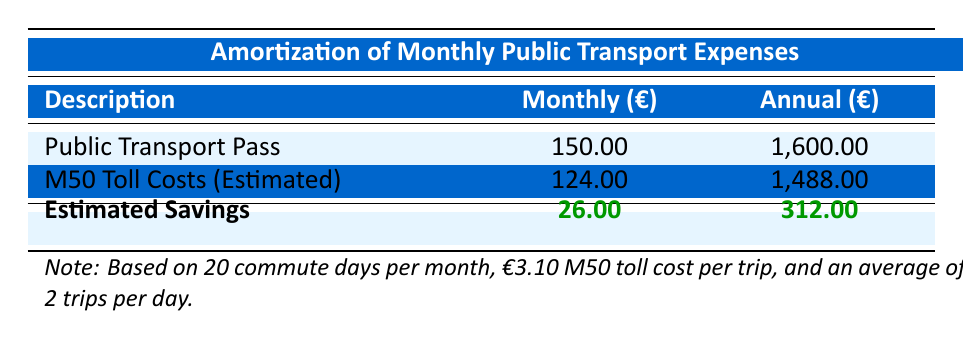What is the monthly cost for a public transport pass? The table directly states that the cost for a Public Transport Pass is €150.00 per month.
Answer: 150.00 How much can a commuter save annually by opting for public transport? The table shows that the Annual Savings from Public Transport is €312.00.
Answer: 312.00 What is the difference in annual costs between the public transport pass and M50 toll costs? The Annual Public Transport Pass cost is €1,600.00 and the Annual M50 Toll Costs are €1,488.00. The difference is calculated as €1,600 - €1,488 = €112.00.
Answer: 112.00 Is the estimated saving from the public transport option higher than the monthly M50 toll cost? The Estimated Savings from Public Transport per month is €26.00, while the Monthly M50 Toll Costs are €124.00. Since €26.00 is less than €124.00, the statement is false.
Answer: No If a commuter switches to public transport, what would be the total toll costs avoided over the year? The Annual M50 Toll Costs amount to €1,488.00, which would be avoided if the commuter switches to public transport, therefore the total avoided toll costs is €1,488.00 over the year.
Answer: 1488.00 What is the average monthly cost of M50 toll costs per commute day if one travels twice a day? The Monthly M50 Toll Costs are €124.00 based on 20 commute days. Therefore, we calculate the average as €124.00 / 20 days = €6.20 per day.
Answer: 6.20 What will be the total annual cost incurred if someone chooses the monthly public transport pass? The table lists the Annual cost of a public transport pass as €1,600.00. Thus, this is the total amount that will be incurred for a year.
Answer: 1600.00 Are the monthly public transport pass costs lower than the monthly M50 costs? The Monthly Public Transport Pass costs €150.00, while the Monthly M50 Toll Costs are €124.00. Since €150.00 is greater than €124.00, the statement is false.
Answer: No How much total savings does a commuter realize over the amortization period of one year? The table states that the Annual Savings from Public Transport is €312.00. This amount represents the total savings over the one year period.
Answer: 312.00 